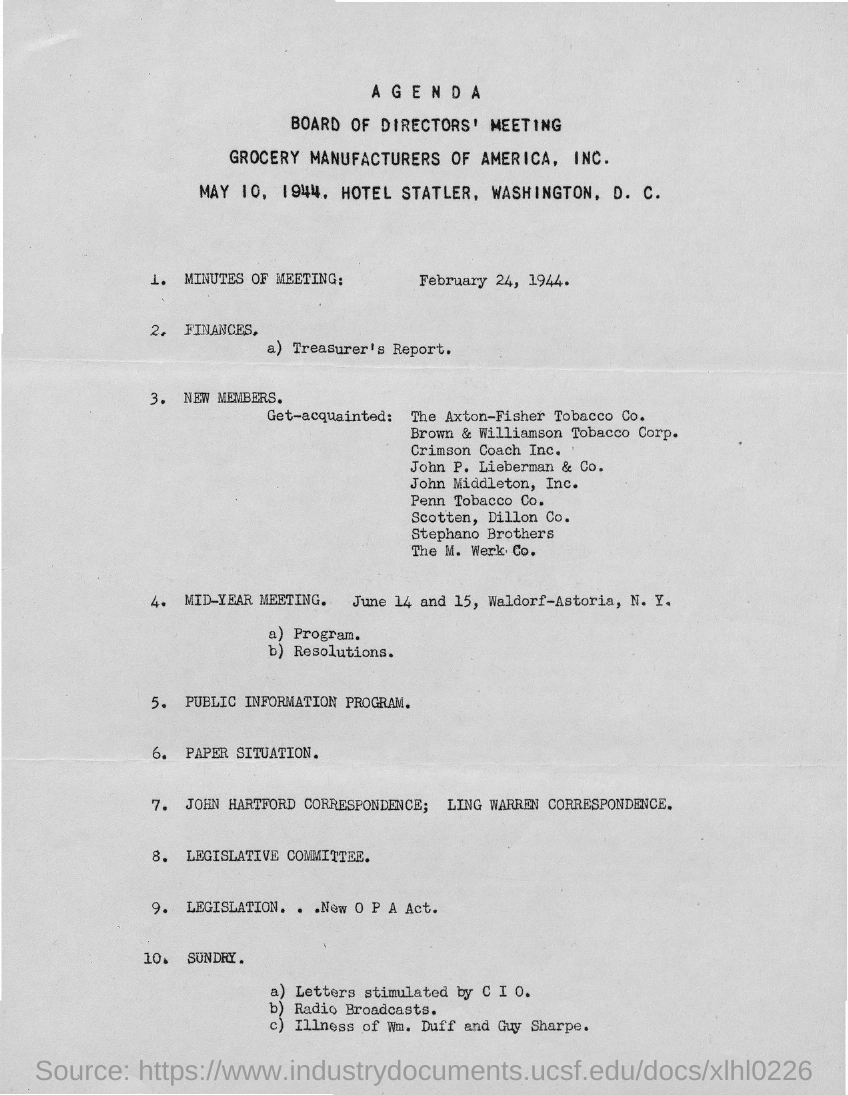What date is the board of directors' meeting of Grocery Manufacturers of America, Inc. held?
Provide a succinct answer. May 10, 1944. Where is the board of directors meeting of Grocery Manufacturers of America, Inc. held?
Offer a terse response. Hotel Statler, Washington, D. C. When & where is the mid-year meeting to be held?
Your answer should be compact. June 14 and 15, Waldorf-Astoria, N. Y. 